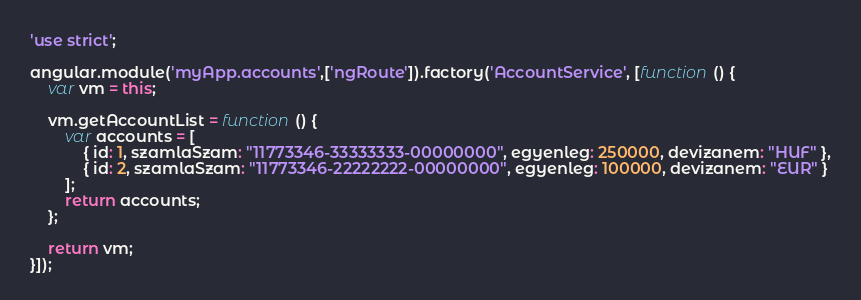<code> <loc_0><loc_0><loc_500><loc_500><_JavaScript_>'use strict';

angular.module('myApp.accounts',['ngRoute']).factory('AccountService', [function () {
    var vm = this;

    vm.getAccountList = function () {
        var accounts = [
            { id: 1, szamlaSzam: "11773346-33333333-00000000", egyenleg: 250000, devizanem: "HUF" },
            { id: 2, szamlaSzam: "11773346-22222222-00000000", egyenleg: 100000, devizanem: "EUR" }
        ];
        return accounts;
    };

    return vm;
}]);</code> 